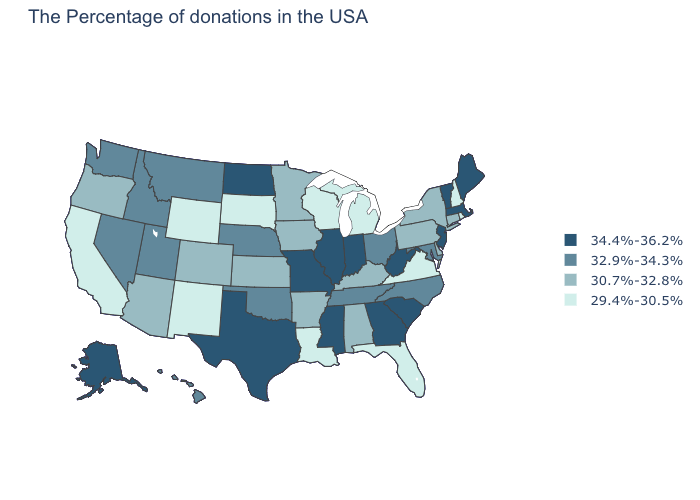Which states have the lowest value in the South?
Give a very brief answer. Virginia, Florida, Louisiana. What is the value of Iowa?
Short answer required. 30.7%-32.8%. What is the value of Iowa?
Be succinct. 30.7%-32.8%. Which states have the lowest value in the USA?
Give a very brief answer. Rhode Island, New Hampshire, Virginia, Florida, Michigan, Wisconsin, Louisiana, South Dakota, Wyoming, New Mexico, California. What is the highest value in the USA?
Keep it brief. 34.4%-36.2%. What is the value of Maryland?
Answer briefly. 32.9%-34.3%. Among the states that border New Hampshire , which have the highest value?
Short answer required. Maine, Massachusetts, Vermont. Does Washington have the highest value in the West?
Write a very short answer. No. Among the states that border Idaho , does Wyoming have the lowest value?
Be succinct. Yes. Does New Hampshire have the highest value in the Northeast?
Keep it brief. No. Among the states that border Arizona , which have the highest value?
Concise answer only. Utah, Nevada. Name the states that have a value in the range 29.4%-30.5%?
Keep it brief. Rhode Island, New Hampshire, Virginia, Florida, Michigan, Wisconsin, Louisiana, South Dakota, Wyoming, New Mexico, California. Does the first symbol in the legend represent the smallest category?
Answer briefly. No. Does Delaware have a higher value than California?
Concise answer only. Yes. What is the value of Missouri?
Answer briefly. 34.4%-36.2%. 